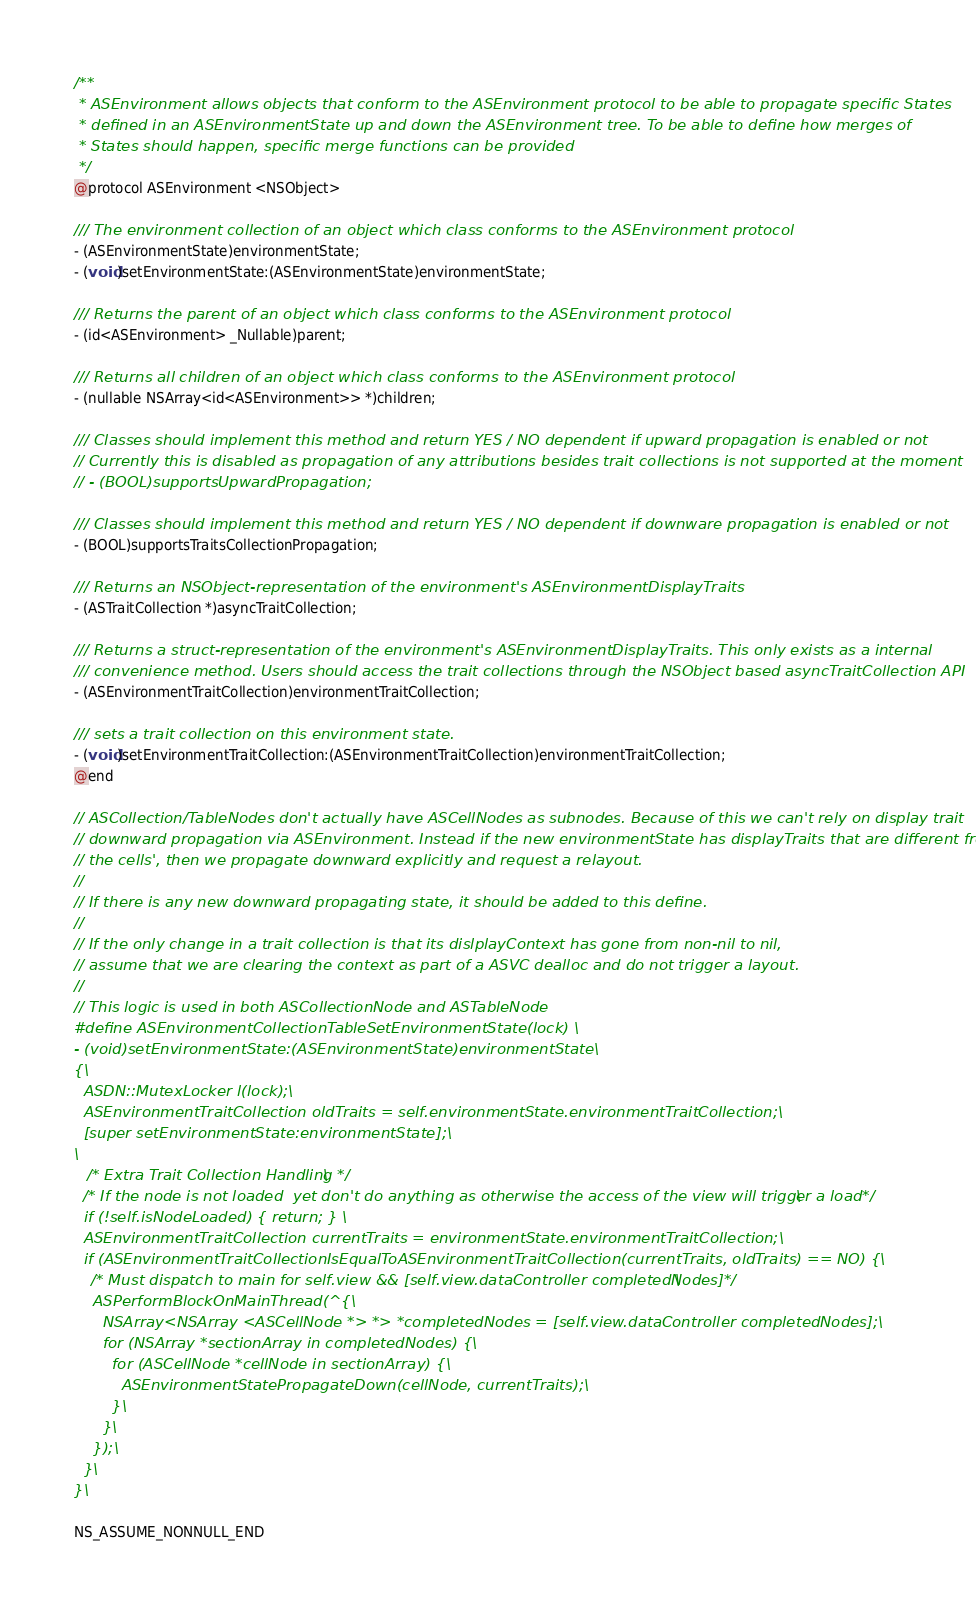Convert code to text. <code><loc_0><loc_0><loc_500><loc_500><_C_>
/**
 * ASEnvironment allows objects that conform to the ASEnvironment protocol to be able to propagate specific States
 * defined in an ASEnvironmentState up and down the ASEnvironment tree. To be able to define how merges of
 * States should happen, specific merge functions can be provided
 */
@protocol ASEnvironment <NSObject>

/// The environment collection of an object which class conforms to the ASEnvironment protocol
- (ASEnvironmentState)environmentState;
- (void)setEnvironmentState:(ASEnvironmentState)environmentState;

/// Returns the parent of an object which class conforms to the ASEnvironment protocol
- (id<ASEnvironment> _Nullable)parent;

/// Returns all children of an object which class conforms to the ASEnvironment protocol
- (nullable NSArray<id<ASEnvironment>> *)children;

/// Classes should implement this method and return YES / NO dependent if upward propagation is enabled or not
// Currently this is disabled as propagation of any attributions besides trait collections is not supported at the moment
// - (BOOL)supportsUpwardPropagation;

/// Classes should implement this method and return YES / NO dependent if downware propagation is enabled or not
- (BOOL)supportsTraitsCollectionPropagation;

/// Returns an NSObject-representation of the environment's ASEnvironmentDisplayTraits
- (ASTraitCollection *)asyncTraitCollection;

/// Returns a struct-representation of the environment's ASEnvironmentDisplayTraits. This only exists as a internal
/// convenience method. Users should access the trait collections through the NSObject based asyncTraitCollection API
- (ASEnvironmentTraitCollection)environmentTraitCollection;

/// sets a trait collection on this environment state.
- (void)setEnvironmentTraitCollection:(ASEnvironmentTraitCollection)environmentTraitCollection;
@end

// ASCollection/TableNodes don't actually have ASCellNodes as subnodes. Because of this we can't rely on display trait
// downward propagation via ASEnvironment. Instead if the new environmentState has displayTraits that are different from
// the cells', then we propagate downward explicitly and request a relayout.
//
// If there is any new downward propagating state, it should be added to this define.
//
// If the only change in a trait collection is that its dislplayContext has gone from non-nil to nil,
// assume that we are clearing the context as part of a ASVC dealloc and do not trigger a layout.
//
// This logic is used in both ASCollectionNode and ASTableNode
#define ASEnvironmentCollectionTableSetEnvironmentState(lock) \
- (void)setEnvironmentState:(ASEnvironmentState)environmentState\
{\
  ASDN::MutexLocker l(lock);\
  ASEnvironmentTraitCollection oldTraits = self.environmentState.environmentTraitCollection;\
  [super setEnvironmentState:environmentState];\
\
   /* Extra Trait Collection Handling */\
  /* If the node is not loaded  yet don't do anything as otherwise the access of the view will trigger a load*/\
  if (!self.isNodeLoaded) { return; } \
  ASEnvironmentTraitCollection currentTraits = environmentState.environmentTraitCollection;\
  if (ASEnvironmentTraitCollectionIsEqualToASEnvironmentTraitCollection(currentTraits, oldTraits) == NO) {\
    /* Must dispatch to main for self.view && [self.view.dataController completedNodes]*/ \
    ASPerformBlockOnMainThread(^{\
      NSArray<NSArray <ASCellNode *> *> *completedNodes = [self.view.dataController completedNodes];\
      for (NSArray *sectionArray in completedNodes) {\
        for (ASCellNode *cellNode in sectionArray) {\
          ASEnvironmentStatePropagateDown(cellNode, currentTraits);\
        }\
      }\
    });\
  }\
}\

NS_ASSUME_NONNULL_END
</code> 